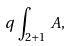<formula> <loc_0><loc_0><loc_500><loc_500>q \, \int _ { 2 + 1 } \, A ,</formula> 